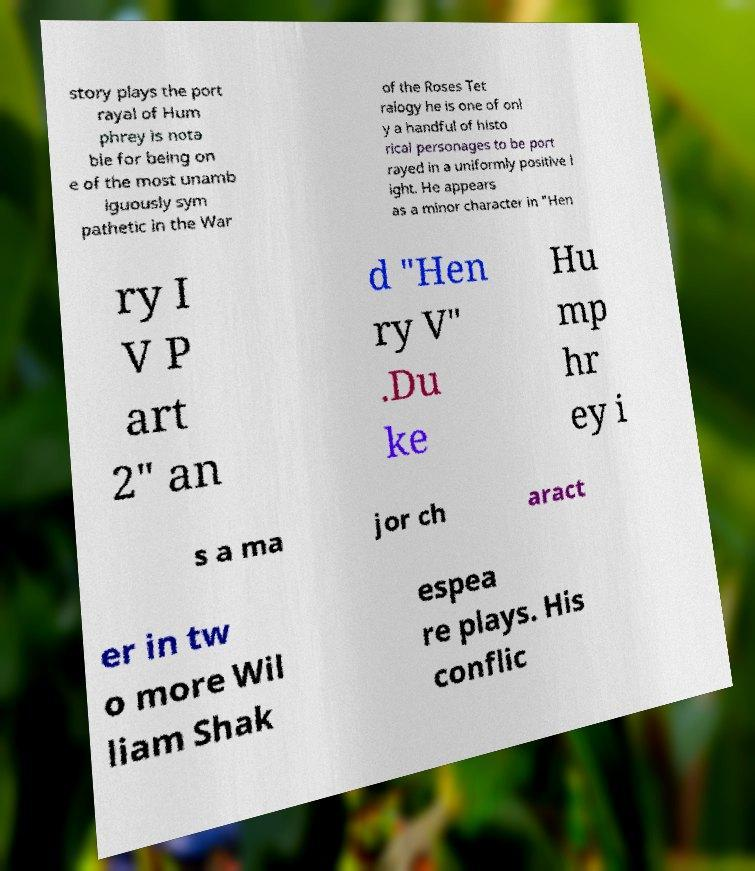For documentation purposes, I need the text within this image transcribed. Could you provide that? story plays the port rayal of Hum phrey is nota ble for being on e of the most unamb iguously sym pathetic in the War of the Roses Tet ralogy he is one of onl y a handful of histo rical personages to be port rayed in a uniformly positive l ight. He appears as a minor character in "Hen ry I V P art 2" an d "Hen ry V" .Du ke Hu mp hr ey i s a ma jor ch aract er in tw o more Wil liam Shak espea re plays. His conflic 